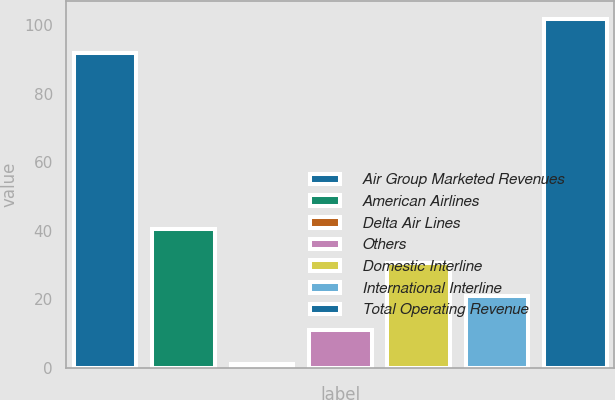Convert chart to OTSL. <chart><loc_0><loc_0><loc_500><loc_500><bar_chart><fcel>Air Group Marketed Revenues<fcel>American Airlines<fcel>Delta Air Lines<fcel>Others<fcel>Domestic Interline<fcel>International Interline<fcel>Total Operating Revenue<nl><fcel>92<fcel>40.6<fcel>1<fcel>10.9<fcel>30.7<fcel>20.8<fcel>101.9<nl></chart> 